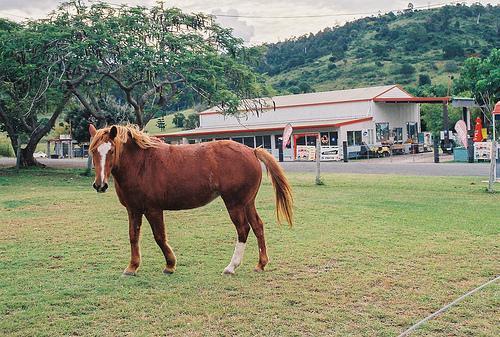How many horses are there?
Give a very brief answer. 1. 